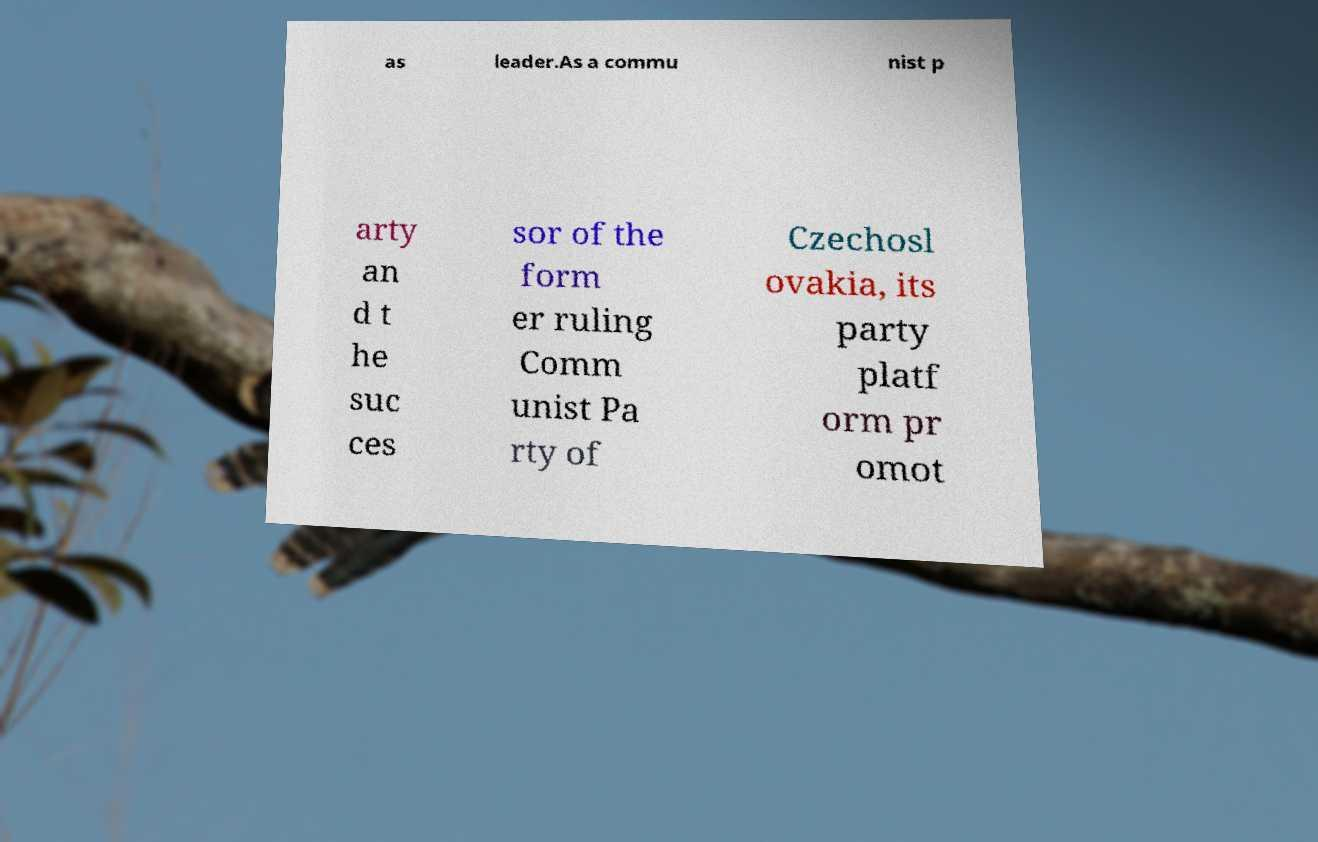Can you read and provide the text displayed in the image?This photo seems to have some interesting text. Can you extract and type it out for me? as leader.As a commu nist p arty an d t he suc ces sor of the form er ruling Comm unist Pa rty of Czechosl ovakia, its party platf orm pr omot 